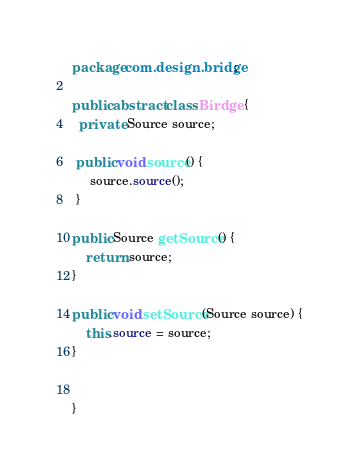<code> <loc_0><loc_0><loc_500><loc_500><_Java_>package com.design.bridge;

public abstract class Birdge {
  private Source source;
  
 public void source() {
	 source.source();
 }

public Source getSource() {
	return source;
}

public void setSource(Source source) {
	this.source = source;
}
  
  
}
</code> 